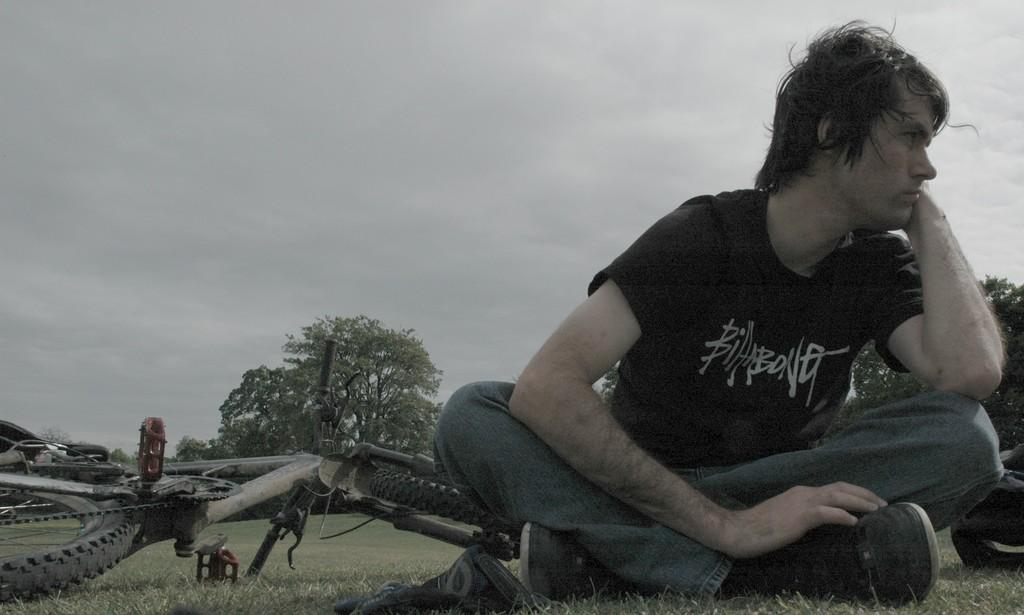What is the man in the image doing? The man is sitting on the grass. What else can be seen on the grass in the image? There are two objects on the grass. What mode of transportation is present in the image? There is a bicycle in the image. What type of natural environment is visible in the image? There are trees in the image. What is visible in the background of the image? The sky is visible in the background of the image. What type of curtain can be seen hanging from the trees in the image? There are no curtains present in the image; only the man, the grass, the objects, the bicycle, the trees, and the sky are visible. 